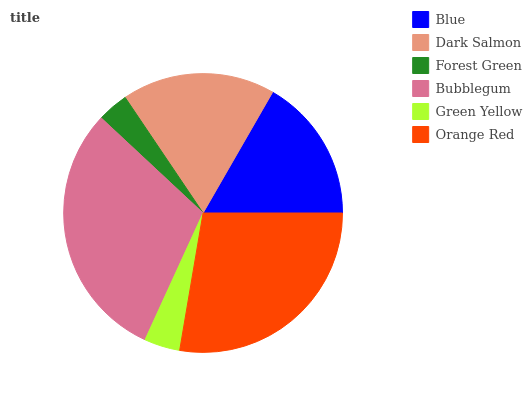Is Forest Green the minimum?
Answer yes or no. Yes. Is Bubblegum the maximum?
Answer yes or no. Yes. Is Dark Salmon the minimum?
Answer yes or no. No. Is Dark Salmon the maximum?
Answer yes or no. No. Is Dark Salmon greater than Blue?
Answer yes or no. Yes. Is Blue less than Dark Salmon?
Answer yes or no. Yes. Is Blue greater than Dark Salmon?
Answer yes or no. No. Is Dark Salmon less than Blue?
Answer yes or no. No. Is Dark Salmon the high median?
Answer yes or no. Yes. Is Blue the low median?
Answer yes or no. Yes. Is Forest Green the high median?
Answer yes or no. No. Is Forest Green the low median?
Answer yes or no. No. 